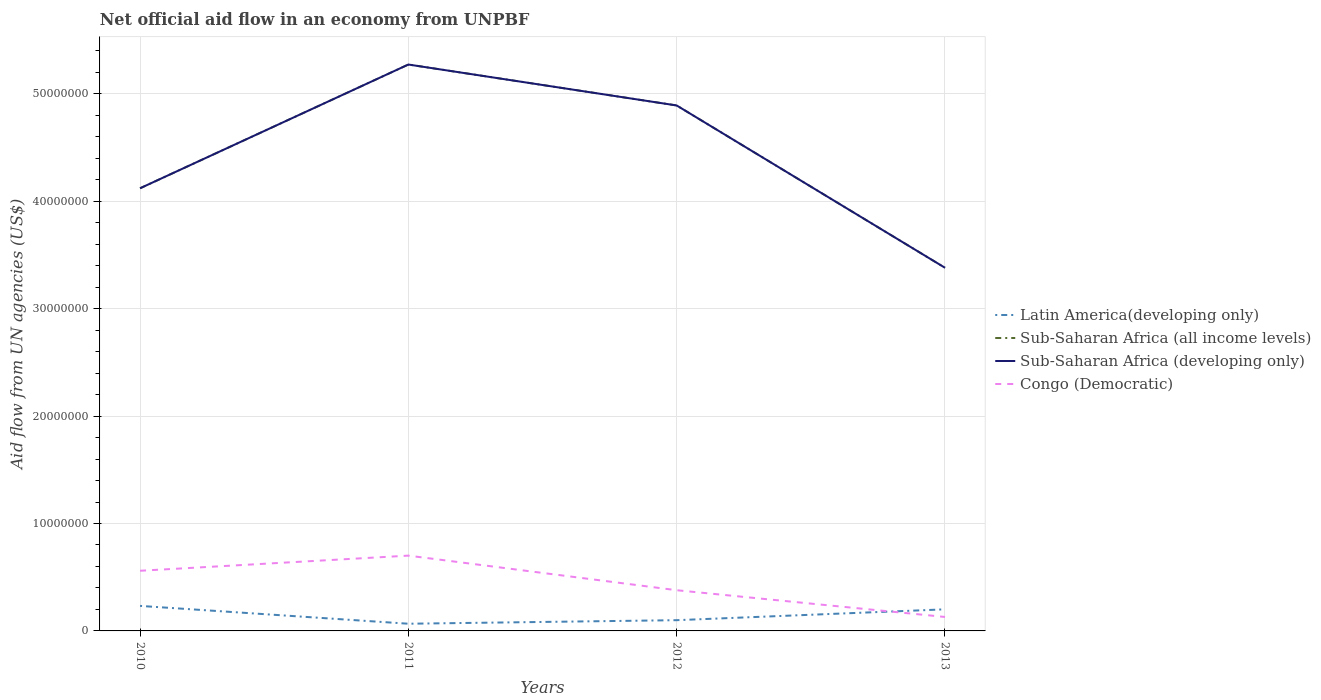Does the line corresponding to Sub-Saharan Africa (developing only) intersect with the line corresponding to Congo (Democratic)?
Your answer should be very brief. No. Is the number of lines equal to the number of legend labels?
Ensure brevity in your answer.  Yes. Across all years, what is the maximum net official aid flow in Sub-Saharan Africa (developing only)?
Your response must be concise. 3.38e+07. In which year was the net official aid flow in Latin America(developing only) maximum?
Provide a short and direct response. 2011. What is the total net official aid flow in Latin America(developing only) in the graph?
Your answer should be compact. -1.01e+06. What is the difference between the highest and the second highest net official aid flow in Latin America(developing only)?
Offer a very short reply. 1.66e+06. How many lines are there?
Your answer should be compact. 4. How many years are there in the graph?
Provide a short and direct response. 4. What is the difference between two consecutive major ticks on the Y-axis?
Provide a succinct answer. 1.00e+07. Does the graph contain any zero values?
Offer a very short reply. No. Where does the legend appear in the graph?
Provide a short and direct response. Center right. How many legend labels are there?
Provide a short and direct response. 4. How are the legend labels stacked?
Provide a succinct answer. Vertical. What is the title of the graph?
Provide a succinct answer. Net official aid flow in an economy from UNPBF. Does "Czech Republic" appear as one of the legend labels in the graph?
Provide a succinct answer. No. What is the label or title of the X-axis?
Your answer should be compact. Years. What is the label or title of the Y-axis?
Make the answer very short. Aid flow from UN agencies (US$). What is the Aid flow from UN agencies (US$) in Latin America(developing only) in 2010?
Give a very brief answer. 2.33e+06. What is the Aid flow from UN agencies (US$) in Sub-Saharan Africa (all income levels) in 2010?
Your response must be concise. 4.12e+07. What is the Aid flow from UN agencies (US$) in Sub-Saharan Africa (developing only) in 2010?
Offer a very short reply. 4.12e+07. What is the Aid flow from UN agencies (US$) in Congo (Democratic) in 2010?
Ensure brevity in your answer.  5.60e+06. What is the Aid flow from UN agencies (US$) of Latin America(developing only) in 2011?
Provide a succinct answer. 6.70e+05. What is the Aid flow from UN agencies (US$) in Sub-Saharan Africa (all income levels) in 2011?
Keep it short and to the point. 5.27e+07. What is the Aid flow from UN agencies (US$) of Sub-Saharan Africa (developing only) in 2011?
Provide a short and direct response. 5.27e+07. What is the Aid flow from UN agencies (US$) of Congo (Democratic) in 2011?
Your answer should be compact. 7.01e+06. What is the Aid flow from UN agencies (US$) in Sub-Saharan Africa (all income levels) in 2012?
Offer a very short reply. 4.89e+07. What is the Aid flow from UN agencies (US$) in Sub-Saharan Africa (developing only) in 2012?
Provide a succinct answer. 4.89e+07. What is the Aid flow from UN agencies (US$) in Congo (Democratic) in 2012?
Provide a succinct answer. 3.79e+06. What is the Aid flow from UN agencies (US$) of Latin America(developing only) in 2013?
Your answer should be very brief. 2.01e+06. What is the Aid flow from UN agencies (US$) in Sub-Saharan Africa (all income levels) in 2013?
Provide a succinct answer. 3.38e+07. What is the Aid flow from UN agencies (US$) in Sub-Saharan Africa (developing only) in 2013?
Your answer should be compact. 3.38e+07. What is the Aid flow from UN agencies (US$) of Congo (Democratic) in 2013?
Offer a very short reply. 1.30e+06. Across all years, what is the maximum Aid flow from UN agencies (US$) of Latin America(developing only)?
Give a very brief answer. 2.33e+06. Across all years, what is the maximum Aid flow from UN agencies (US$) of Sub-Saharan Africa (all income levels)?
Make the answer very short. 5.27e+07. Across all years, what is the maximum Aid flow from UN agencies (US$) of Sub-Saharan Africa (developing only)?
Give a very brief answer. 5.27e+07. Across all years, what is the maximum Aid flow from UN agencies (US$) in Congo (Democratic)?
Offer a very short reply. 7.01e+06. Across all years, what is the minimum Aid flow from UN agencies (US$) in Latin America(developing only)?
Provide a short and direct response. 6.70e+05. Across all years, what is the minimum Aid flow from UN agencies (US$) of Sub-Saharan Africa (all income levels)?
Your answer should be very brief. 3.38e+07. Across all years, what is the minimum Aid flow from UN agencies (US$) in Sub-Saharan Africa (developing only)?
Your answer should be very brief. 3.38e+07. Across all years, what is the minimum Aid flow from UN agencies (US$) in Congo (Democratic)?
Offer a very short reply. 1.30e+06. What is the total Aid flow from UN agencies (US$) in Latin America(developing only) in the graph?
Offer a very short reply. 6.01e+06. What is the total Aid flow from UN agencies (US$) in Sub-Saharan Africa (all income levels) in the graph?
Make the answer very short. 1.77e+08. What is the total Aid flow from UN agencies (US$) in Sub-Saharan Africa (developing only) in the graph?
Make the answer very short. 1.77e+08. What is the total Aid flow from UN agencies (US$) of Congo (Democratic) in the graph?
Your answer should be very brief. 1.77e+07. What is the difference between the Aid flow from UN agencies (US$) in Latin America(developing only) in 2010 and that in 2011?
Provide a succinct answer. 1.66e+06. What is the difference between the Aid flow from UN agencies (US$) of Sub-Saharan Africa (all income levels) in 2010 and that in 2011?
Ensure brevity in your answer.  -1.15e+07. What is the difference between the Aid flow from UN agencies (US$) of Sub-Saharan Africa (developing only) in 2010 and that in 2011?
Offer a very short reply. -1.15e+07. What is the difference between the Aid flow from UN agencies (US$) of Congo (Democratic) in 2010 and that in 2011?
Make the answer very short. -1.41e+06. What is the difference between the Aid flow from UN agencies (US$) of Latin America(developing only) in 2010 and that in 2012?
Offer a very short reply. 1.33e+06. What is the difference between the Aid flow from UN agencies (US$) of Sub-Saharan Africa (all income levels) in 2010 and that in 2012?
Give a very brief answer. -7.71e+06. What is the difference between the Aid flow from UN agencies (US$) of Sub-Saharan Africa (developing only) in 2010 and that in 2012?
Give a very brief answer. -7.71e+06. What is the difference between the Aid flow from UN agencies (US$) in Congo (Democratic) in 2010 and that in 2012?
Ensure brevity in your answer.  1.81e+06. What is the difference between the Aid flow from UN agencies (US$) in Sub-Saharan Africa (all income levels) in 2010 and that in 2013?
Your response must be concise. 7.40e+06. What is the difference between the Aid flow from UN agencies (US$) in Sub-Saharan Africa (developing only) in 2010 and that in 2013?
Ensure brevity in your answer.  7.40e+06. What is the difference between the Aid flow from UN agencies (US$) of Congo (Democratic) in 2010 and that in 2013?
Your answer should be compact. 4.30e+06. What is the difference between the Aid flow from UN agencies (US$) in Latin America(developing only) in 2011 and that in 2012?
Your response must be concise. -3.30e+05. What is the difference between the Aid flow from UN agencies (US$) of Sub-Saharan Africa (all income levels) in 2011 and that in 2012?
Make the answer very short. 3.81e+06. What is the difference between the Aid flow from UN agencies (US$) in Sub-Saharan Africa (developing only) in 2011 and that in 2012?
Your answer should be compact. 3.81e+06. What is the difference between the Aid flow from UN agencies (US$) in Congo (Democratic) in 2011 and that in 2012?
Keep it short and to the point. 3.22e+06. What is the difference between the Aid flow from UN agencies (US$) of Latin America(developing only) in 2011 and that in 2013?
Give a very brief answer. -1.34e+06. What is the difference between the Aid flow from UN agencies (US$) of Sub-Saharan Africa (all income levels) in 2011 and that in 2013?
Your answer should be very brief. 1.89e+07. What is the difference between the Aid flow from UN agencies (US$) of Sub-Saharan Africa (developing only) in 2011 and that in 2013?
Provide a short and direct response. 1.89e+07. What is the difference between the Aid flow from UN agencies (US$) of Congo (Democratic) in 2011 and that in 2013?
Your answer should be compact. 5.71e+06. What is the difference between the Aid flow from UN agencies (US$) of Latin America(developing only) in 2012 and that in 2013?
Your answer should be very brief. -1.01e+06. What is the difference between the Aid flow from UN agencies (US$) of Sub-Saharan Africa (all income levels) in 2012 and that in 2013?
Ensure brevity in your answer.  1.51e+07. What is the difference between the Aid flow from UN agencies (US$) in Sub-Saharan Africa (developing only) in 2012 and that in 2013?
Provide a short and direct response. 1.51e+07. What is the difference between the Aid flow from UN agencies (US$) of Congo (Democratic) in 2012 and that in 2013?
Your response must be concise. 2.49e+06. What is the difference between the Aid flow from UN agencies (US$) in Latin America(developing only) in 2010 and the Aid flow from UN agencies (US$) in Sub-Saharan Africa (all income levels) in 2011?
Ensure brevity in your answer.  -5.04e+07. What is the difference between the Aid flow from UN agencies (US$) in Latin America(developing only) in 2010 and the Aid flow from UN agencies (US$) in Sub-Saharan Africa (developing only) in 2011?
Offer a very short reply. -5.04e+07. What is the difference between the Aid flow from UN agencies (US$) in Latin America(developing only) in 2010 and the Aid flow from UN agencies (US$) in Congo (Democratic) in 2011?
Offer a terse response. -4.68e+06. What is the difference between the Aid flow from UN agencies (US$) in Sub-Saharan Africa (all income levels) in 2010 and the Aid flow from UN agencies (US$) in Sub-Saharan Africa (developing only) in 2011?
Your response must be concise. -1.15e+07. What is the difference between the Aid flow from UN agencies (US$) of Sub-Saharan Africa (all income levels) in 2010 and the Aid flow from UN agencies (US$) of Congo (Democratic) in 2011?
Your response must be concise. 3.42e+07. What is the difference between the Aid flow from UN agencies (US$) of Sub-Saharan Africa (developing only) in 2010 and the Aid flow from UN agencies (US$) of Congo (Democratic) in 2011?
Offer a terse response. 3.42e+07. What is the difference between the Aid flow from UN agencies (US$) of Latin America(developing only) in 2010 and the Aid flow from UN agencies (US$) of Sub-Saharan Africa (all income levels) in 2012?
Your response must be concise. -4.66e+07. What is the difference between the Aid flow from UN agencies (US$) of Latin America(developing only) in 2010 and the Aid flow from UN agencies (US$) of Sub-Saharan Africa (developing only) in 2012?
Provide a short and direct response. -4.66e+07. What is the difference between the Aid flow from UN agencies (US$) of Latin America(developing only) in 2010 and the Aid flow from UN agencies (US$) of Congo (Democratic) in 2012?
Make the answer very short. -1.46e+06. What is the difference between the Aid flow from UN agencies (US$) in Sub-Saharan Africa (all income levels) in 2010 and the Aid flow from UN agencies (US$) in Sub-Saharan Africa (developing only) in 2012?
Give a very brief answer. -7.71e+06. What is the difference between the Aid flow from UN agencies (US$) in Sub-Saharan Africa (all income levels) in 2010 and the Aid flow from UN agencies (US$) in Congo (Democratic) in 2012?
Your answer should be compact. 3.74e+07. What is the difference between the Aid flow from UN agencies (US$) of Sub-Saharan Africa (developing only) in 2010 and the Aid flow from UN agencies (US$) of Congo (Democratic) in 2012?
Your answer should be very brief. 3.74e+07. What is the difference between the Aid flow from UN agencies (US$) in Latin America(developing only) in 2010 and the Aid flow from UN agencies (US$) in Sub-Saharan Africa (all income levels) in 2013?
Your response must be concise. -3.15e+07. What is the difference between the Aid flow from UN agencies (US$) of Latin America(developing only) in 2010 and the Aid flow from UN agencies (US$) of Sub-Saharan Africa (developing only) in 2013?
Offer a terse response. -3.15e+07. What is the difference between the Aid flow from UN agencies (US$) in Latin America(developing only) in 2010 and the Aid flow from UN agencies (US$) in Congo (Democratic) in 2013?
Ensure brevity in your answer.  1.03e+06. What is the difference between the Aid flow from UN agencies (US$) in Sub-Saharan Africa (all income levels) in 2010 and the Aid flow from UN agencies (US$) in Sub-Saharan Africa (developing only) in 2013?
Ensure brevity in your answer.  7.40e+06. What is the difference between the Aid flow from UN agencies (US$) of Sub-Saharan Africa (all income levels) in 2010 and the Aid flow from UN agencies (US$) of Congo (Democratic) in 2013?
Your answer should be very brief. 3.99e+07. What is the difference between the Aid flow from UN agencies (US$) in Sub-Saharan Africa (developing only) in 2010 and the Aid flow from UN agencies (US$) in Congo (Democratic) in 2013?
Your answer should be very brief. 3.99e+07. What is the difference between the Aid flow from UN agencies (US$) in Latin America(developing only) in 2011 and the Aid flow from UN agencies (US$) in Sub-Saharan Africa (all income levels) in 2012?
Offer a very short reply. -4.82e+07. What is the difference between the Aid flow from UN agencies (US$) of Latin America(developing only) in 2011 and the Aid flow from UN agencies (US$) of Sub-Saharan Africa (developing only) in 2012?
Your answer should be compact. -4.82e+07. What is the difference between the Aid flow from UN agencies (US$) in Latin America(developing only) in 2011 and the Aid flow from UN agencies (US$) in Congo (Democratic) in 2012?
Provide a succinct answer. -3.12e+06. What is the difference between the Aid flow from UN agencies (US$) of Sub-Saharan Africa (all income levels) in 2011 and the Aid flow from UN agencies (US$) of Sub-Saharan Africa (developing only) in 2012?
Keep it short and to the point. 3.81e+06. What is the difference between the Aid flow from UN agencies (US$) of Sub-Saharan Africa (all income levels) in 2011 and the Aid flow from UN agencies (US$) of Congo (Democratic) in 2012?
Make the answer very short. 4.89e+07. What is the difference between the Aid flow from UN agencies (US$) of Sub-Saharan Africa (developing only) in 2011 and the Aid flow from UN agencies (US$) of Congo (Democratic) in 2012?
Ensure brevity in your answer.  4.89e+07. What is the difference between the Aid flow from UN agencies (US$) in Latin America(developing only) in 2011 and the Aid flow from UN agencies (US$) in Sub-Saharan Africa (all income levels) in 2013?
Your response must be concise. -3.31e+07. What is the difference between the Aid flow from UN agencies (US$) of Latin America(developing only) in 2011 and the Aid flow from UN agencies (US$) of Sub-Saharan Africa (developing only) in 2013?
Offer a very short reply. -3.31e+07. What is the difference between the Aid flow from UN agencies (US$) in Latin America(developing only) in 2011 and the Aid flow from UN agencies (US$) in Congo (Democratic) in 2013?
Your answer should be very brief. -6.30e+05. What is the difference between the Aid flow from UN agencies (US$) in Sub-Saharan Africa (all income levels) in 2011 and the Aid flow from UN agencies (US$) in Sub-Saharan Africa (developing only) in 2013?
Your response must be concise. 1.89e+07. What is the difference between the Aid flow from UN agencies (US$) in Sub-Saharan Africa (all income levels) in 2011 and the Aid flow from UN agencies (US$) in Congo (Democratic) in 2013?
Provide a succinct answer. 5.14e+07. What is the difference between the Aid flow from UN agencies (US$) of Sub-Saharan Africa (developing only) in 2011 and the Aid flow from UN agencies (US$) of Congo (Democratic) in 2013?
Offer a terse response. 5.14e+07. What is the difference between the Aid flow from UN agencies (US$) of Latin America(developing only) in 2012 and the Aid flow from UN agencies (US$) of Sub-Saharan Africa (all income levels) in 2013?
Keep it short and to the point. -3.28e+07. What is the difference between the Aid flow from UN agencies (US$) in Latin America(developing only) in 2012 and the Aid flow from UN agencies (US$) in Sub-Saharan Africa (developing only) in 2013?
Make the answer very short. -3.28e+07. What is the difference between the Aid flow from UN agencies (US$) of Sub-Saharan Africa (all income levels) in 2012 and the Aid flow from UN agencies (US$) of Sub-Saharan Africa (developing only) in 2013?
Make the answer very short. 1.51e+07. What is the difference between the Aid flow from UN agencies (US$) of Sub-Saharan Africa (all income levels) in 2012 and the Aid flow from UN agencies (US$) of Congo (Democratic) in 2013?
Keep it short and to the point. 4.76e+07. What is the difference between the Aid flow from UN agencies (US$) of Sub-Saharan Africa (developing only) in 2012 and the Aid flow from UN agencies (US$) of Congo (Democratic) in 2013?
Ensure brevity in your answer.  4.76e+07. What is the average Aid flow from UN agencies (US$) in Latin America(developing only) per year?
Provide a succinct answer. 1.50e+06. What is the average Aid flow from UN agencies (US$) in Sub-Saharan Africa (all income levels) per year?
Offer a very short reply. 4.42e+07. What is the average Aid flow from UN agencies (US$) of Sub-Saharan Africa (developing only) per year?
Provide a short and direct response. 4.42e+07. What is the average Aid flow from UN agencies (US$) in Congo (Democratic) per year?
Keep it short and to the point. 4.42e+06. In the year 2010, what is the difference between the Aid flow from UN agencies (US$) in Latin America(developing only) and Aid flow from UN agencies (US$) in Sub-Saharan Africa (all income levels)?
Your response must be concise. -3.89e+07. In the year 2010, what is the difference between the Aid flow from UN agencies (US$) of Latin America(developing only) and Aid flow from UN agencies (US$) of Sub-Saharan Africa (developing only)?
Keep it short and to the point. -3.89e+07. In the year 2010, what is the difference between the Aid flow from UN agencies (US$) of Latin America(developing only) and Aid flow from UN agencies (US$) of Congo (Democratic)?
Your response must be concise. -3.27e+06. In the year 2010, what is the difference between the Aid flow from UN agencies (US$) in Sub-Saharan Africa (all income levels) and Aid flow from UN agencies (US$) in Sub-Saharan Africa (developing only)?
Offer a very short reply. 0. In the year 2010, what is the difference between the Aid flow from UN agencies (US$) in Sub-Saharan Africa (all income levels) and Aid flow from UN agencies (US$) in Congo (Democratic)?
Keep it short and to the point. 3.56e+07. In the year 2010, what is the difference between the Aid flow from UN agencies (US$) of Sub-Saharan Africa (developing only) and Aid flow from UN agencies (US$) of Congo (Democratic)?
Ensure brevity in your answer.  3.56e+07. In the year 2011, what is the difference between the Aid flow from UN agencies (US$) of Latin America(developing only) and Aid flow from UN agencies (US$) of Sub-Saharan Africa (all income levels)?
Give a very brief answer. -5.21e+07. In the year 2011, what is the difference between the Aid flow from UN agencies (US$) in Latin America(developing only) and Aid flow from UN agencies (US$) in Sub-Saharan Africa (developing only)?
Offer a very short reply. -5.21e+07. In the year 2011, what is the difference between the Aid flow from UN agencies (US$) in Latin America(developing only) and Aid flow from UN agencies (US$) in Congo (Democratic)?
Ensure brevity in your answer.  -6.34e+06. In the year 2011, what is the difference between the Aid flow from UN agencies (US$) of Sub-Saharan Africa (all income levels) and Aid flow from UN agencies (US$) of Sub-Saharan Africa (developing only)?
Ensure brevity in your answer.  0. In the year 2011, what is the difference between the Aid flow from UN agencies (US$) of Sub-Saharan Africa (all income levels) and Aid flow from UN agencies (US$) of Congo (Democratic)?
Your answer should be very brief. 4.57e+07. In the year 2011, what is the difference between the Aid flow from UN agencies (US$) of Sub-Saharan Africa (developing only) and Aid flow from UN agencies (US$) of Congo (Democratic)?
Offer a terse response. 4.57e+07. In the year 2012, what is the difference between the Aid flow from UN agencies (US$) in Latin America(developing only) and Aid flow from UN agencies (US$) in Sub-Saharan Africa (all income levels)?
Offer a terse response. -4.79e+07. In the year 2012, what is the difference between the Aid flow from UN agencies (US$) in Latin America(developing only) and Aid flow from UN agencies (US$) in Sub-Saharan Africa (developing only)?
Your answer should be very brief. -4.79e+07. In the year 2012, what is the difference between the Aid flow from UN agencies (US$) of Latin America(developing only) and Aid flow from UN agencies (US$) of Congo (Democratic)?
Provide a short and direct response. -2.79e+06. In the year 2012, what is the difference between the Aid flow from UN agencies (US$) in Sub-Saharan Africa (all income levels) and Aid flow from UN agencies (US$) in Congo (Democratic)?
Offer a terse response. 4.51e+07. In the year 2012, what is the difference between the Aid flow from UN agencies (US$) of Sub-Saharan Africa (developing only) and Aid flow from UN agencies (US$) of Congo (Democratic)?
Your response must be concise. 4.51e+07. In the year 2013, what is the difference between the Aid flow from UN agencies (US$) of Latin America(developing only) and Aid flow from UN agencies (US$) of Sub-Saharan Africa (all income levels)?
Your answer should be very brief. -3.18e+07. In the year 2013, what is the difference between the Aid flow from UN agencies (US$) in Latin America(developing only) and Aid flow from UN agencies (US$) in Sub-Saharan Africa (developing only)?
Make the answer very short. -3.18e+07. In the year 2013, what is the difference between the Aid flow from UN agencies (US$) in Latin America(developing only) and Aid flow from UN agencies (US$) in Congo (Democratic)?
Your answer should be very brief. 7.10e+05. In the year 2013, what is the difference between the Aid flow from UN agencies (US$) of Sub-Saharan Africa (all income levels) and Aid flow from UN agencies (US$) of Sub-Saharan Africa (developing only)?
Ensure brevity in your answer.  0. In the year 2013, what is the difference between the Aid flow from UN agencies (US$) in Sub-Saharan Africa (all income levels) and Aid flow from UN agencies (US$) in Congo (Democratic)?
Make the answer very short. 3.25e+07. In the year 2013, what is the difference between the Aid flow from UN agencies (US$) in Sub-Saharan Africa (developing only) and Aid flow from UN agencies (US$) in Congo (Democratic)?
Provide a succinct answer. 3.25e+07. What is the ratio of the Aid flow from UN agencies (US$) in Latin America(developing only) in 2010 to that in 2011?
Ensure brevity in your answer.  3.48. What is the ratio of the Aid flow from UN agencies (US$) in Sub-Saharan Africa (all income levels) in 2010 to that in 2011?
Keep it short and to the point. 0.78. What is the ratio of the Aid flow from UN agencies (US$) in Sub-Saharan Africa (developing only) in 2010 to that in 2011?
Ensure brevity in your answer.  0.78. What is the ratio of the Aid flow from UN agencies (US$) in Congo (Democratic) in 2010 to that in 2011?
Offer a terse response. 0.8. What is the ratio of the Aid flow from UN agencies (US$) of Latin America(developing only) in 2010 to that in 2012?
Your answer should be very brief. 2.33. What is the ratio of the Aid flow from UN agencies (US$) of Sub-Saharan Africa (all income levels) in 2010 to that in 2012?
Offer a very short reply. 0.84. What is the ratio of the Aid flow from UN agencies (US$) in Sub-Saharan Africa (developing only) in 2010 to that in 2012?
Your response must be concise. 0.84. What is the ratio of the Aid flow from UN agencies (US$) of Congo (Democratic) in 2010 to that in 2012?
Offer a very short reply. 1.48. What is the ratio of the Aid flow from UN agencies (US$) of Latin America(developing only) in 2010 to that in 2013?
Ensure brevity in your answer.  1.16. What is the ratio of the Aid flow from UN agencies (US$) in Sub-Saharan Africa (all income levels) in 2010 to that in 2013?
Your answer should be compact. 1.22. What is the ratio of the Aid flow from UN agencies (US$) in Sub-Saharan Africa (developing only) in 2010 to that in 2013?
Provide a succinct answer. 1.22. What is the ratio of the Aid flow from UN agencies (US$) of Congo (Democratic) in 2010 to that in 2013?
Offer a terse response. 4.31. What is the ratio of the Aid flow from UN agencies (US$) in Latin America(developing only) in 2011 to that in 2012?
Offer a terse response. 0.67. What is the ratio of the Aid flow from UN agencies (US$) in Sub-Saharan Africa (all income levels) in 2011 to that in 2012?
Give a very brief answer. 1.08. What is the ratio of the Aid flow from UN agencies (US$) in Sub-Saharan Africa (developing only) in 2011 to that in 2012?
Provide a succinct answer. 1.08. What is the ratio of the Aid flow from UN agencies (US$) of Congo (Democratic) in 2011 to that in 2012?
Give a very brief answer. 1.85. What is the ratio of the Aid flow from UN agencies (US$) in Latin America(developing only) in 2011 to that in 2013?
Offer a very short reply. 0.33. What is the ratio of the Aid flow from UN agencies (US$) in Sub-Saharan Africa (all income levels) in 2011 to that in 2013?
Provide a succinct answer. 1.56. What is the ratio of the Aid flow from UN agencies (US$) in Sub-Saharan Africa (developing only) in 2011 to that in 2013?
Your answer should be compact. 1.56. What is the ratio of the Aid flow from UN agencies (US$) in Congo (Democratic) in 2011 to that in 2013?
Make the answer very short. 5.39. What is the ratio of the Aid flow from UN agencies (US$) in Latin America(developing only) in 2012 to that in 2013?
Keep it short and to the point. 0.5. What is the ratio of the Aid flow from UN agencies (US$) of Sub-Saharan Africa (all income levels) in 2012 to that in 2013?
Offer a terse response. 1.45. What is the ratio of the Aid flow from UN agencies (US$) of Sub-Saharan Africa (developing only) in 2012 to that in 2013?
Your response must be concise. 1.45. What is the ratio of the Aid flow from UN agencies (US$) in Congo (Democratic) in 2012 to that in 2013?
Offer a terse response. 2.92. What is the difference between the highest and the second highest Aid flow from UN agencies (US$) in Sub-Saharan Africa (all income levels)?
Your response must be concise. 3.81e+06. What is the difference between the highest and the second highest Aid flow from UN agencies (US$) in Sub-Saharan Africa (developing only)?
Your answer should be compact. 3.81e+06. What is the difference between the highest and the second highest Aid flow from UN agencies (US$) of Congo (Democratic)?
Provide a short and direct response. 1.41e+06. What is the difference between the highest and the lowest Aid flow from UN agencies (US$) of Latin America(developing only)?
Make the answer very short. 1.66e+06. What is the difference between the highest and the lowest Aid flow from UN agencies (US$) of Sub-Saharan Africa (all income levels)?
Provide a short and direct response. 1.89e+07. What is the difference between the highest and the lowest Aid flow from UN agencies (US$) in Sub-Saharan Africa (developing only)?
Offer a very short reply. 1.89e+07. What is the difference between the highest and the lowest Aid flow from UN agencies (US$) in Congo (Democratic)?
Your response must be concise. 5.71e+06. 